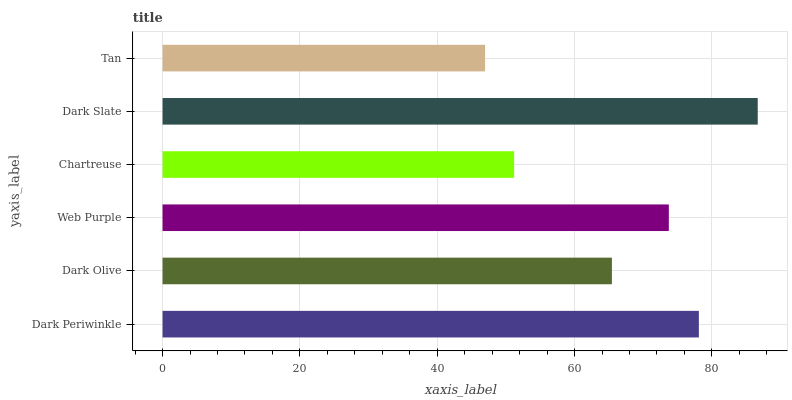Is Tan the minimum?
Answer yes or no. Yes. Is Dark Slate the maximum?
Answer yes or no. Yes. Is Dark Olive the minimum?
Answer yes or no. No. Is Dark Olive the maximum?
Answer yes or no. No. Is Dark Periwinkle greater than Dark Olive?
Answer yes or no. Yes. Is Dark Olive less than Dark Periwinkle?
Answer yes or no. Yes. Is Dark Olive greater than Dark Periwinkle?
Answer yes or no. No. Is Dark Periwinkle less than Dark Olive?
Answer yes or no. No. Is Web Purple the high median?
Answer yes or no. Yes. Is Dark Olive the low median?
Answer yes or no. Yes. Is Tan the high median?
Answer yes or no. No. Is Web Purple the low median?
Answer yes or no. No. 